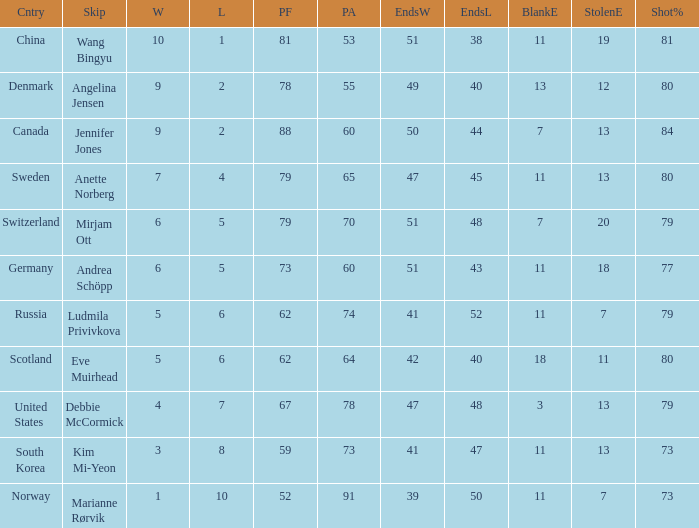Parse the table in full. {'header': ['Cntry', 'Skip', 'W', 'L', 'PF', 'PA', 'EndsW', 'EndsL', 'BlankE', 'StolenE', 'Shot%'], 'rows': [['China', 'Wang Bingyu', '10', '1', '81', '53', '51', '38', '11', '19', '81'], ['Denmark', 'Angelina Jensen', '9', '2', '78', '55', '49', '40', '13', '12', '80'], ['Canada', 'Jennifer Jones', '9', '2', '88', '60', '50', '44', '7', '13', '84'], ['Sweden', 'Anette Norberg', '7', '4', '79', '65', '47', '45', '11', '13', '80'], ['Switzerland', 'Mirjam Ott', '6', '5', '79', '70', '51', '48', '7', '20', '79'], ['Germany', 'Andrea Schöpp', '6', '5', '73', '60', '51', '43', '11', '18', '77'], ['Russia', 'Ludmila Privivkova', '5', '6', '62', '74', '41', '52', '11', '7', '79'], ['Scotland', 'Eve Muirhead', '5', '6', '62', '64', '42', '40', '18', '11', '80'], ['United States', 'Debbie McCormick', '4', '7', '67', '78', '47', '48', '3', '13', '79'], ['South Korea', 'Kim Mi-Yeon', '3', '8', '59', '73', '41', '47', '11', '13', '73'], ['Norway', 'Marianne Rørvik', '1', '10', '52', '91', '39', '50', '11', '7', '73']]} What is Norway's least ends lost? 50.0. 